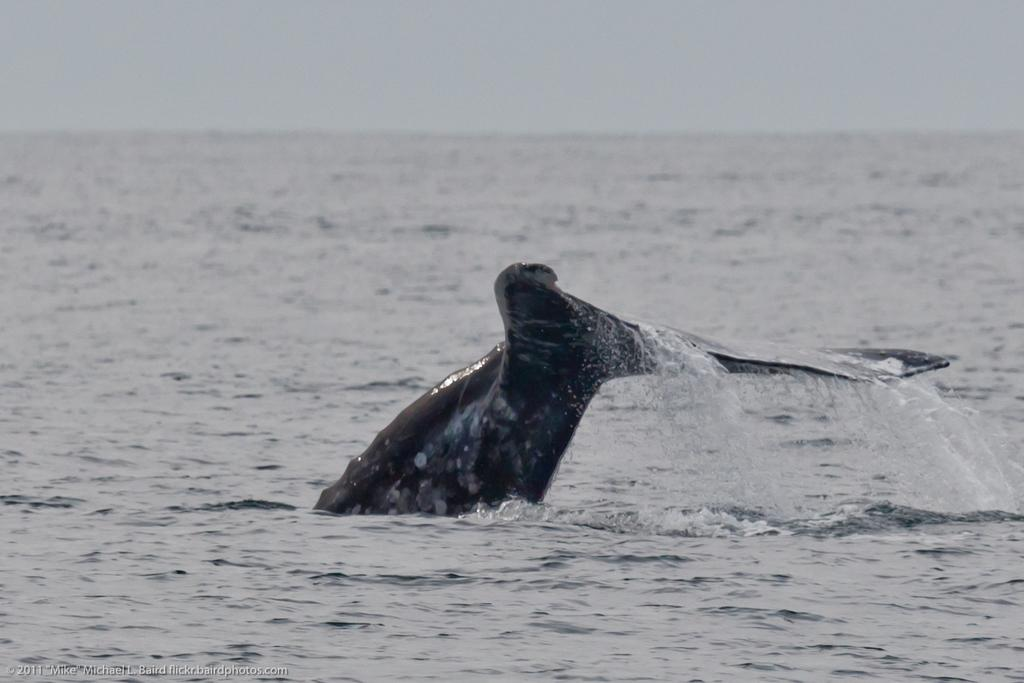What type of water is present in the image? There is ocean water in the image. What type of marine life can be seen in the image? A part of a fish with a tail is visible in the image. What is visible in the background of the image? There is a sky visible in the background of the image. What type of rake is being used to catch the fish in the image? There is no rake present in the image; the fish is visible with only its tail. 